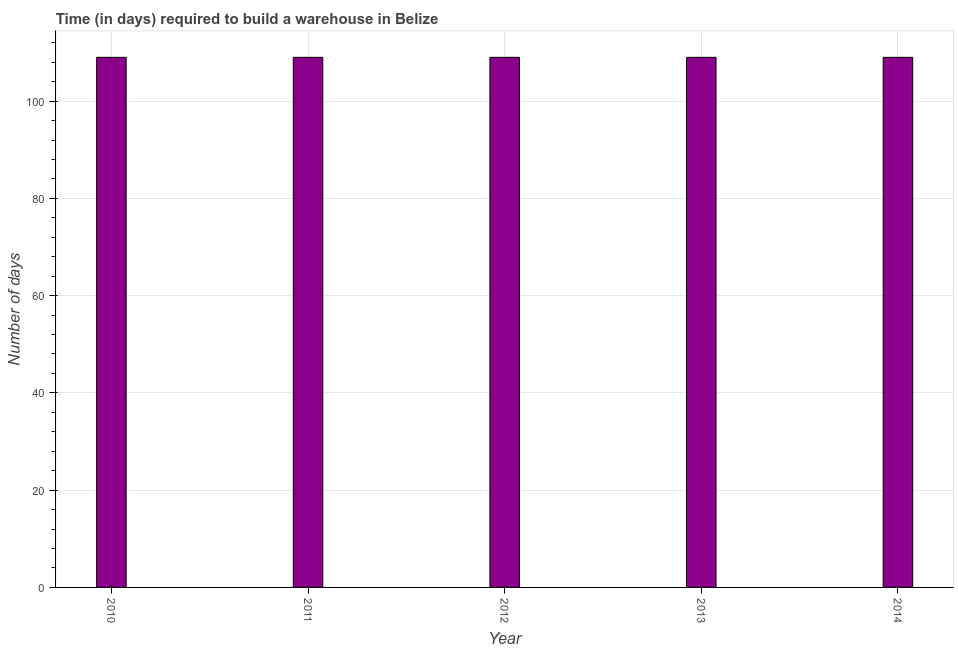Does the graph contain grids?
Provide a succinct answer. Yes. What is the title of the graph?
Your response must be concise. Time (in days) required to build a warehouse in Belize. What is the label or title of the Y-axis?
Offer a very short reply. Number of days. What is the time required to build a warehouse in 2011?
Your response must be concise. 109. Across all years, what is the maximum time required to build a warehouse?
Offer a terse response. 109. Across all years, what is the minimum time required to build a warehouse?
Make the answer very short. 109. What is the sum of the time required to build a warehouse?
Your answer should be compact. 545. What is the average time required to build a warehouse per year?
Give a very brief answer. 109. What is the median time required to build a warehouse?
Provide a succinct answer. 109. In how many years, is the time required to build a warehouse greater than 72 days?
Offer a terse response. 5. What is the ratio of the time required to build a warehouse in 2010 to that in 2012?
Ensure brevity in your answer.  1. Is the time required to build a warehouse in 2010 less than that in 2011?
Provide a succinct answer. No. Is the difference between the time required to build a warehouse in 2013 and 2014 greater than the difference between any two years?
Keep it short and to the point. Yes. Is the sum of the time required to build a warehouse in 2011 and 2013 greater than the maximum time required to build a warehouse across all years?
Give a very brief answer. Yes. In how many years, is the time required to build a warehouse greater than the average time required to build a warehouse taken over all years?
Your answer should be compact. 0. Are all the bars in the graph horizontal?
Make the answer very short. No. What is the difference between two consecutive major ticks on the Y-axis?
Keep it short and to the point. 20. Are the values on the major ticks of Y-axis written in scientific E-notation?
Your answer should be very brief. No. What is the Number of days in 2010?
Make the answer very short. 109. What is the Number of days in 2011?
Give a very brief answer. 109. What is the Number of days in 2012?
Provide a short and direct response. 109. What is the Number of days in 2013?
Provide a succinct answer. 109. What is the Number of days of 2014?
Make the answer very short. 109. What is the difference between the Number of days in 2010 and 2012?
Ensure brevity in your answer.  0. What is the difference between the Number of days in 2010 and 2013?
Your answer should be compact. 0. What is the difference between the Number of days in 2011 and 2012?
Offer a terse response. 0. What is the difference between the Number of days in 2011 and 2013?
Your response must be concise. 0. What is the difference between the Number of days in 2011 and 2014?
Give a very brief answer. 0. What is the difference between the Number of days in 2012 and 2014?
Your answer should be very brief. 0. What is the ratio of the Number of days in 2010 to that in 2011?
Offer a very short reply. 1. What is the ratio of the Number of days in 2010 to that in 2014?
Your response must be concise. 1. What is the ratio of the Number of days in 2011 to that in 2012?
Make the answer very short. 1. What is the ratio of the Number of days in 2011 to that in 2013?
Make the answer very short. 1. What is the ratio of the Number of days in 2012 to that in 2014?
Offer a very short reply. 1. 